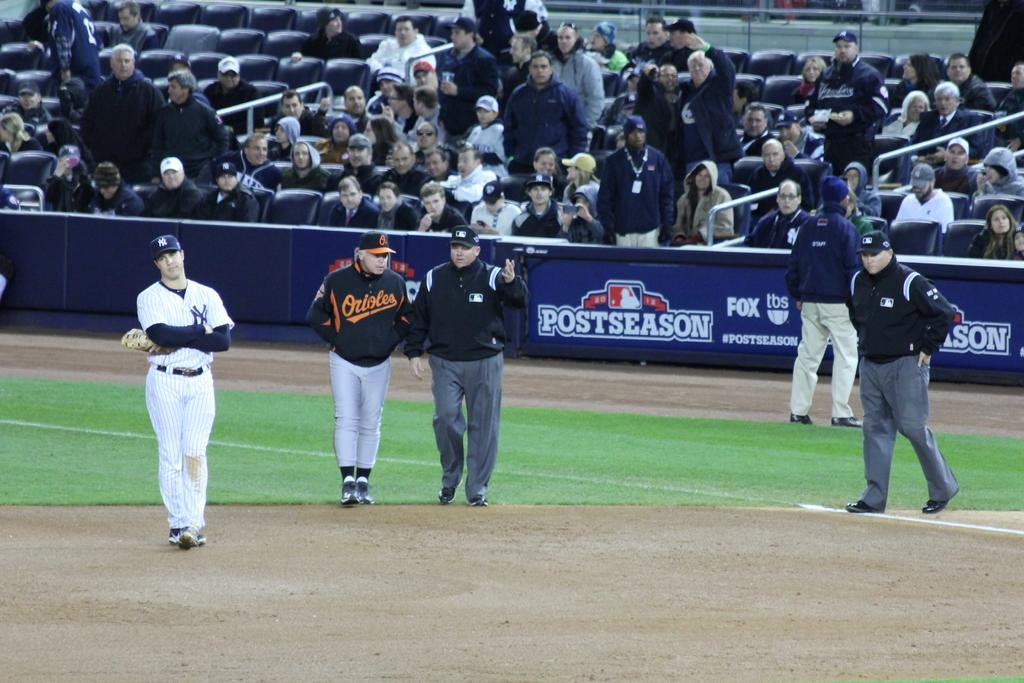<image>
Render a clear and concise summary of the photo. ny yankees and baltimore orioles postseason baseball game 